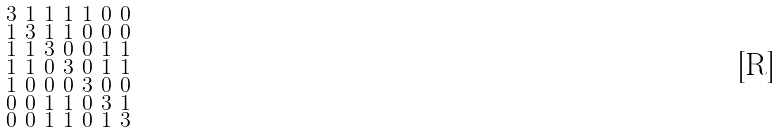<formula> <loc_0><loc_0><loc_500><loc_500>\begin{smallmatrix} 3 & 1 & 1 & 1 & 1 & 0 & 0 \\ 1 & 3 & 1 & 1 & 0 & 0 & 0 \\ 1 & 1 & 3 & 0 & 0 & 1 & 1 \\ 1 & 1 & 0 & 3 & 0 & 1 & 1 \\ 1 & 0 & 0 & 0 & 3 & 0 & 0 \\ 0 & 0 & 1 & 1 & 0 & 3 & 1 \\ 0 & 0 & 1 & 1 & 0 & 1 & 3 \end{smallmatrix}</formula> 